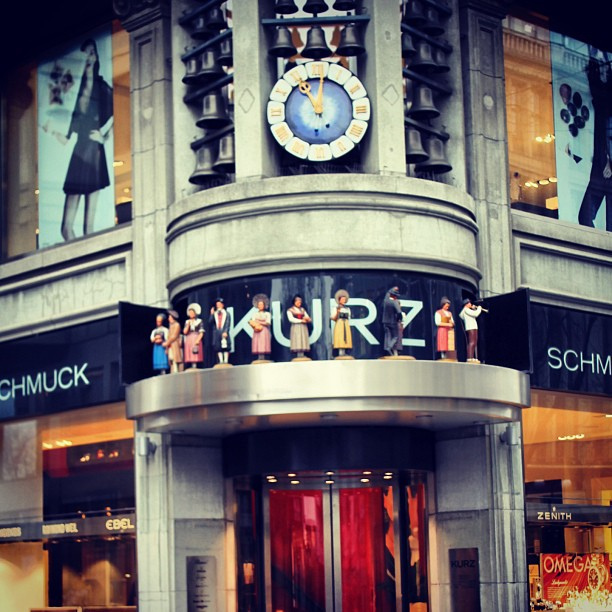Identify the text contained in this image. CHMUCK EBEL ZENITH OMEGA SCHM KURZ 